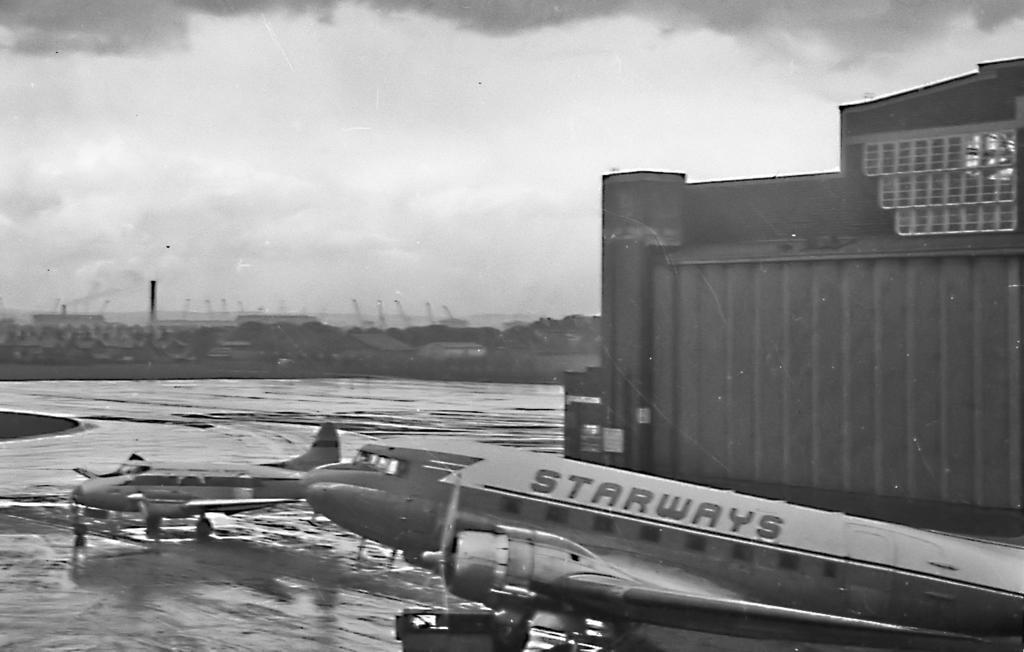Describe this image in one or two sentences. This is a black and white image and here we can see buildings, poles, trees and there are aeroplanes on the road. At the top, there is sky. 